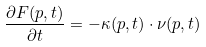Convert formula to latex. <formula><loc_0><loc_0><loc_500><loc_500>\frac { \partial F ( p , t ) } { \partial t } = - \kappa ( p , t ) \cdot \nu ( p , t )</formula> 